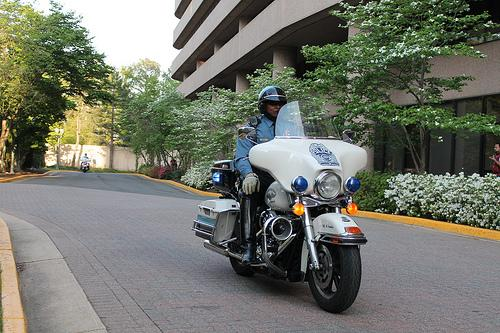Mention three items on the motorcycle's front end. The front center light, a blue side light, and an orange side light. Identify an accessory the police officer is wearing. The police officer is wearing a black protective helmet. What is the primary subject in the image and their action? A police officer riding a motorcycle, headed downhill, steering with less than two hands on the handlebars. Describe one detail about the officer's uniform. The uniform the officer is wearing is blue. Mention two colors that represent lights on the police officer's motorcycle. There are blue and orange side lights on the motorcycle. Briefly describe an accessory in the image belonging to the motorcycle rider. The police officer has a hand in a glove, resting on the knee. What type of road surface is depicted in the image? The street is made of concrete bricks. What is the additional person in the image doing? There is a person behind a hedge, possibly watching the scene. Mention one remarkable feature of the building in the image. The building is the color gray. What type of footwear is the police officer using? The police officer is wearing black and high leather boots. 